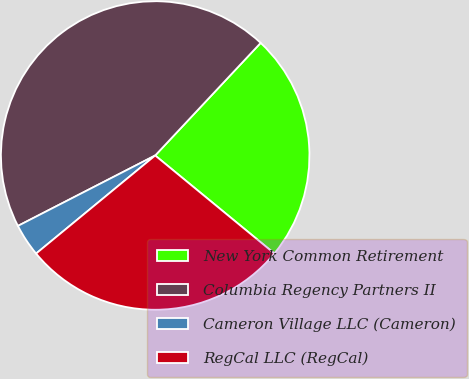Convert chart. <chart><loc_0><loc_0><loc_500><loc_500><pie_chart><fcel>New York Common Retirement<fcel>Columbia Regency Partners II<fcel>Cameron Village LLC (Cameron)<fcel>RegCal LLC (RegCal)<nl><fcel>23.97%<fcel>44.52%<fcel>3.42%<fcel>28.08%<nl></chart> 